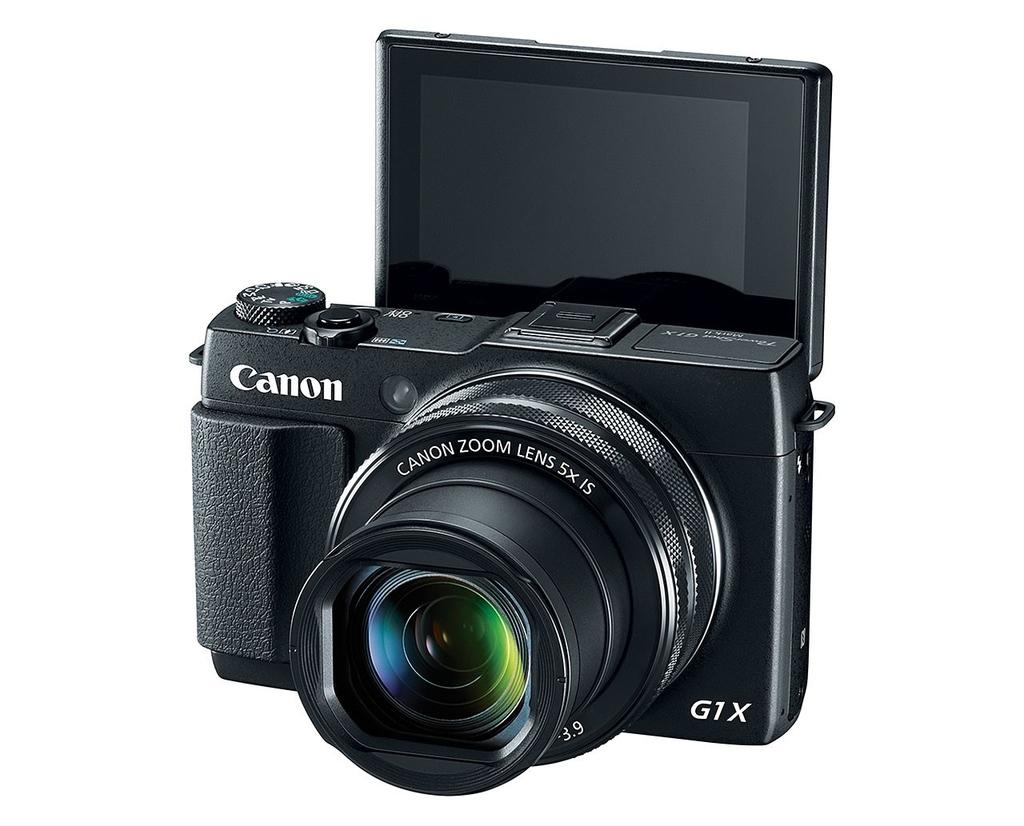What object is the main subject of the image? There is a black camera in the image. Is there any text or writing on the camera? Yes, there is something written on the camera. What color is the background of the image? The background of the image is white. What feature is associated with the camera? There is a screen associated with the camera. How many buns are visible on the camera in the image? There are no buns present in the image; it features a black camera with a screen and writing on it. Are there any children riding bikes in the background of the image? There are no children or bikes visible in the image; it has a white background with a black camera as the main subject. 